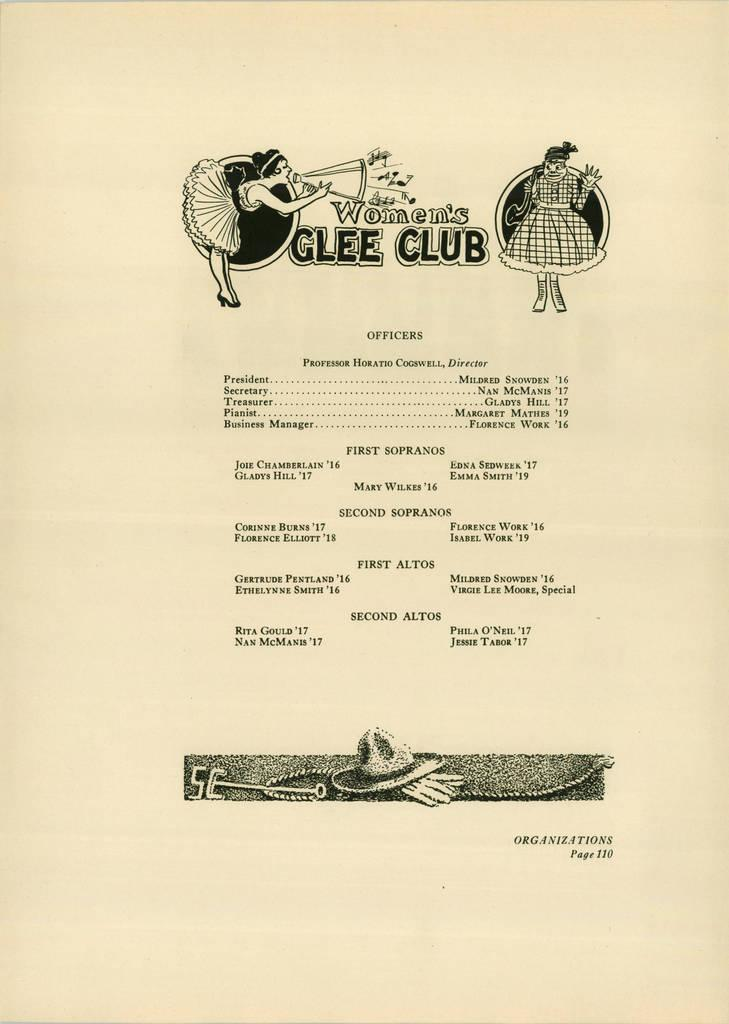What is present on the paper in the image? There is a paper in the image. What can be found on the paper besides the paper itself? There is text and cartoon images on the paper. What type of club is being used to write on the paper in the image? There is no club present in the image, and the paper does not show any signs of being written on with a club. 